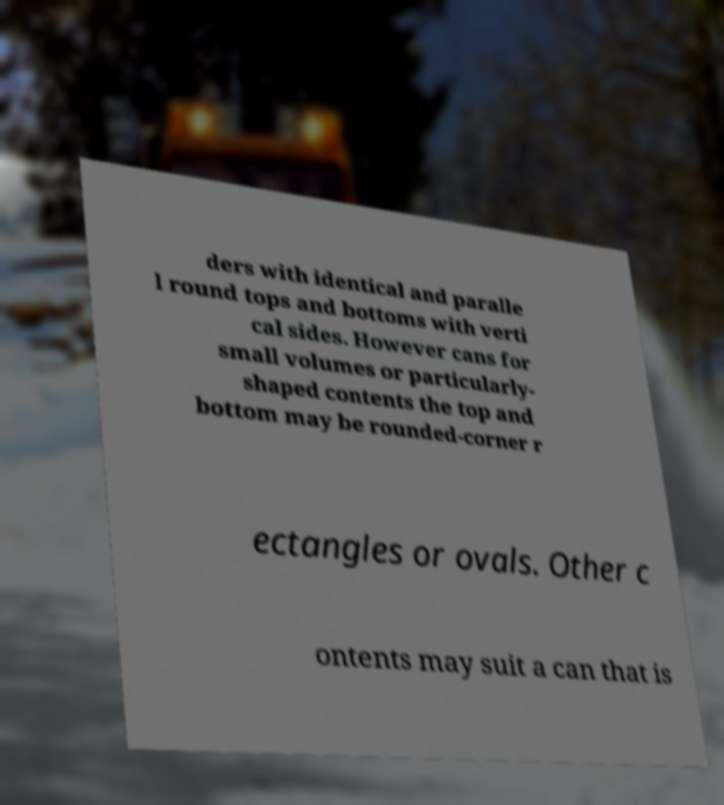Please read and relay the text visible in this image. What does it say? ders with identical and paralle l round tops and bottoms with verti cal sides. However cans for small volumes or particularly- shaped contents the top and bottom may be rounded-corner r ectangles or ovals. Other c ontents may suit a can that is 